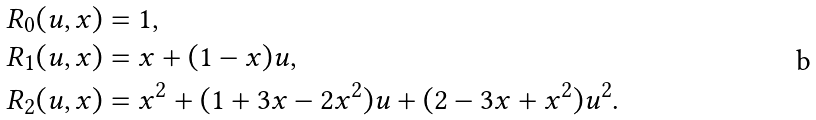Convert formula to latex. <formula><loc_0><loc_0><loc_500><loc_500>R _ { 0 } ( u , x ) & = 1 , \\ R _ { 1 } ( u , x ) & = x + ( 1 - x ) u , \\ R _ { 2 } ( u , x ) & = x ^ { 2 } + ( 1 + 3 x - 2 x ^ { 2 } ) u + ( 2 - 3 x + x ^ { 2 } ) u ^ { 2 } .</formula> 